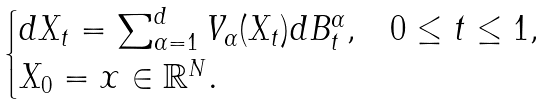Convert formula to latex. <formula><loc_0><loc_0><loc_500><loc_500>\begin{cases} d X _ { t } = \sum _ { \alpha = 1 } ^ { d } V _ { \alpha } ( X _ { t } ) d B _ { t } ^ { \alpha } , & 0 \leq t \leq 1 , \\ X _ { 0 } = x \in \mathbb { R } ^ { N } . \end{cases}</formula> 